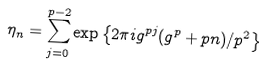<formula> <loc_0><loc_0><loc_500><loc_500>\eta _ { n } = \sum _ { j = 0 } ^ { p - 2 } \exp \left \{ 2 \pi i g ^ { p j } ( g ^ { p } + p n ) / p ^ { 2 } \right \}</formula> 